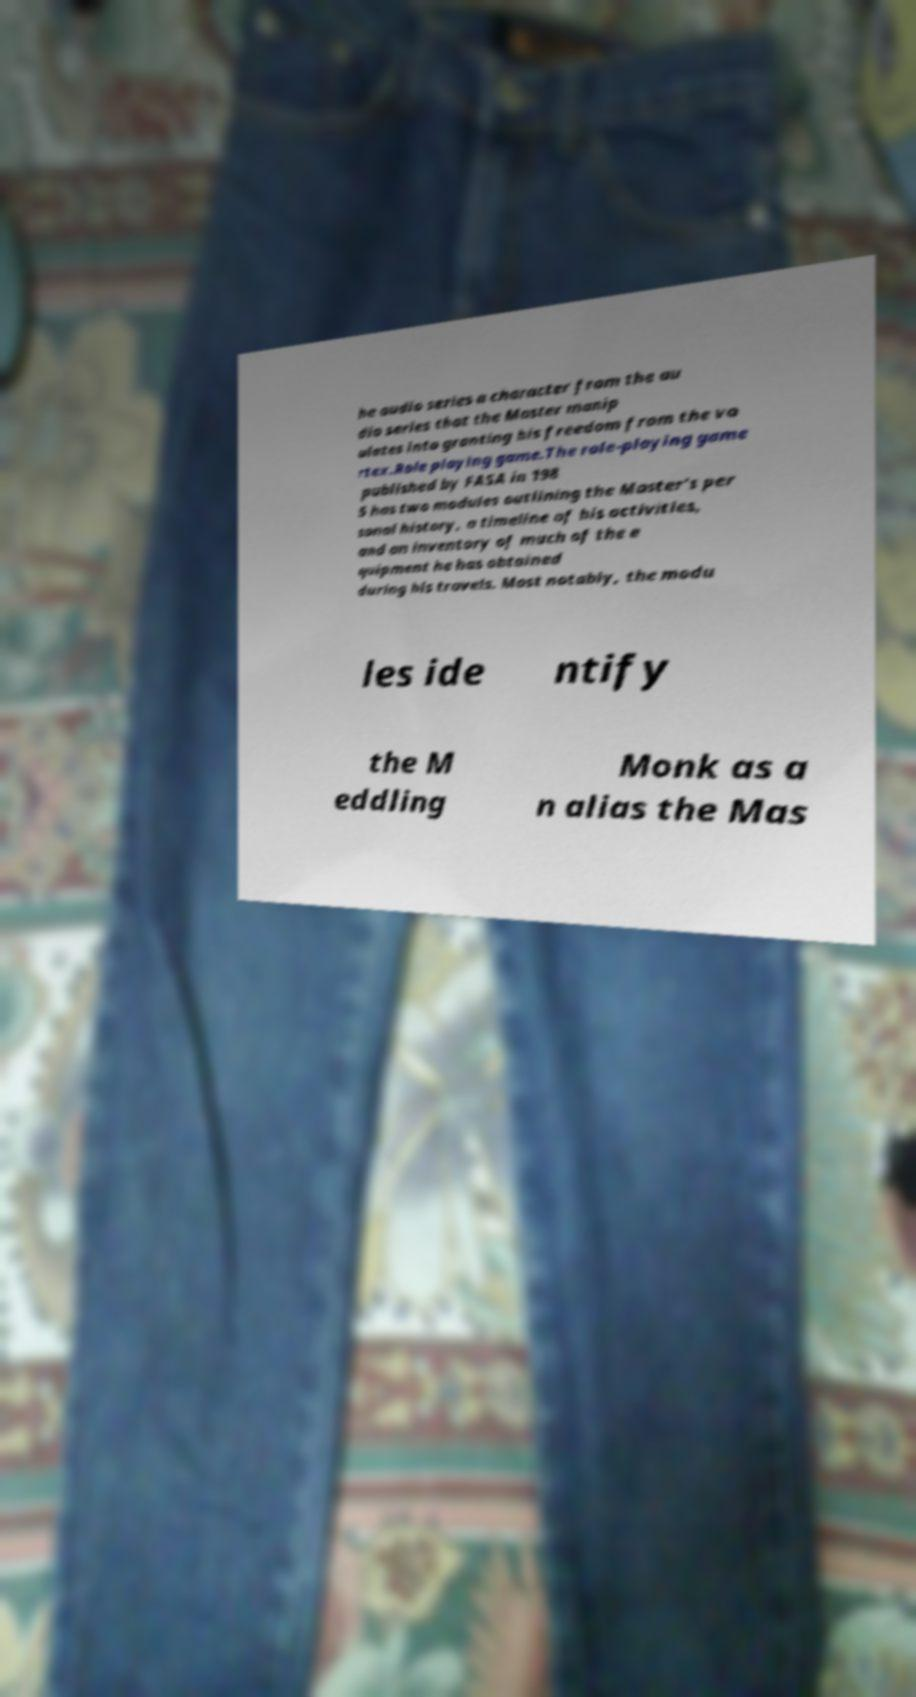What messages or text are displayed in this image? I need them in a readable, typed format. he audio series a character from the au dio series that the Master manip ulates into granting his freedom from the vo rtex.Role playing game.The role-playing game published by FASA in 198 5 has two modules outlining the Master's per sonal history, a timeline of his activities, and an inventory of much of the e quipment he has obtained during his travels. Most notably, the modu les ide ntify the M eddling Monk as a n alias the Mas 